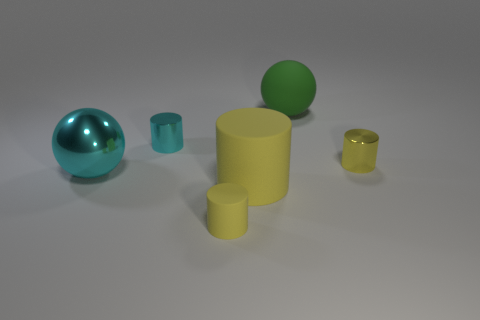Subtract all green balls. How many yellow cylinders are left? 3 Subtract all blue balls. Subtract all blue cubes. How many balls are left? 2 Add 1 small cyan spheres. How many objects exist? 7 Subtract all spheres. How many objects are left? 4 Add 3 tiny shiny cylinders. How many tiny shiny cylinders are left? 5 Add 5 small green metal blocks. How many small green metal blocks exist? 5 Subtract 3 yellow cylinders. How many objects are left? 3 Subtract all small shiny cylinders. Subtract all matte balls. How many objects are left? 3 